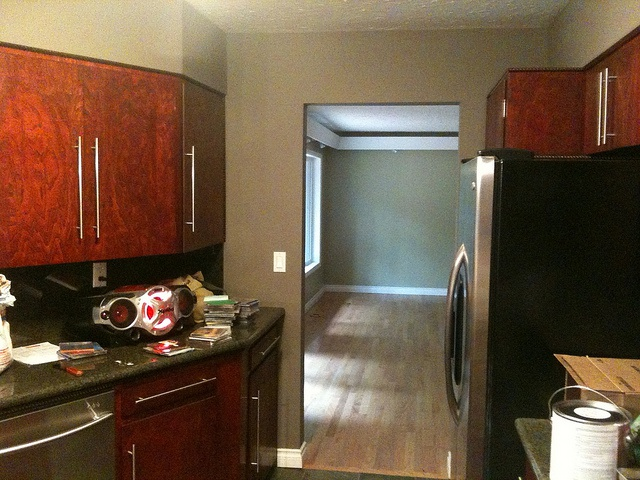Describe the objects in this image and their specific colors. I can see refrigerator in tan, black, and gray tones, book in tan and gray tones, book in tan, gray, and maroon tones, book in tan, beige, and green tones, and book in tan and gray tones in this image. 